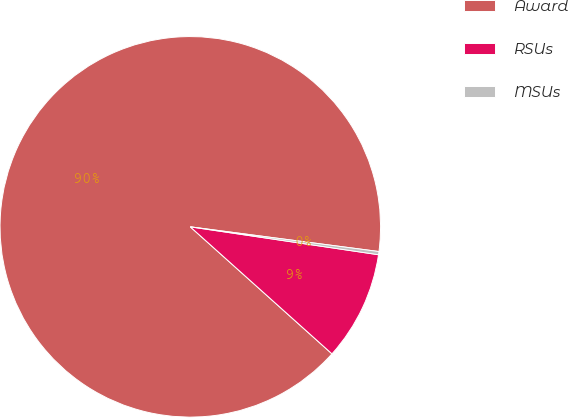Convert chart to OTSL. <chart><loc_0><loc_0><loc_500><loc_500><pie_chart><fcel>Award<fcel>RSUs<fcel>MSUs<nl><fcel>90.44%<fcel>9.29%<fcel>0.27%<nl></chart> 